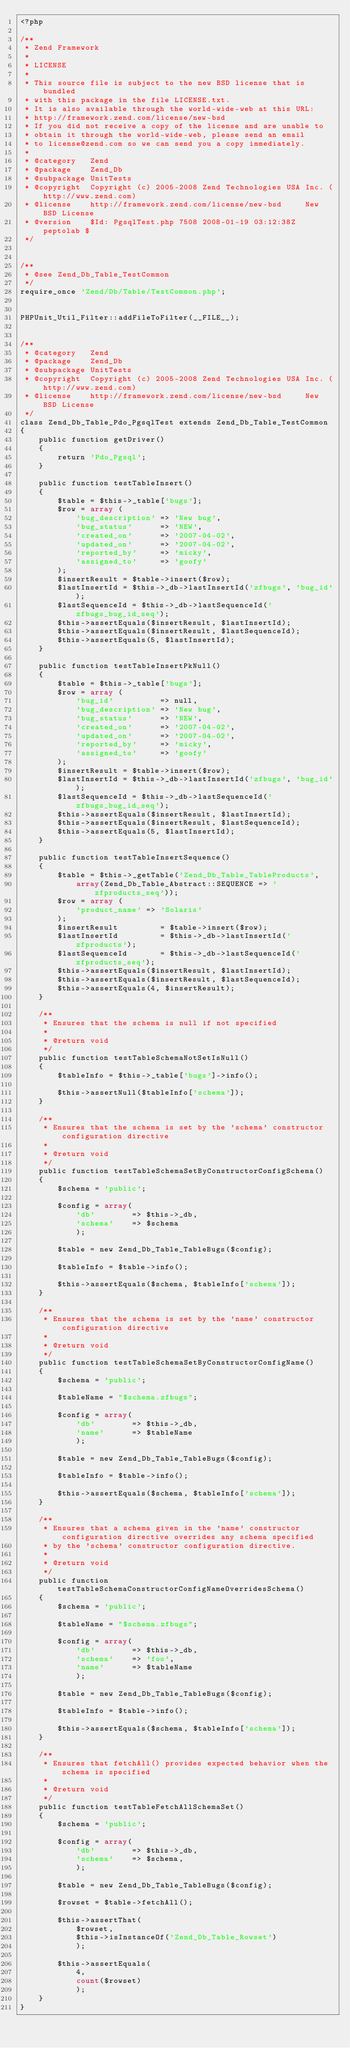<code> <loc_0><loc_0><loc_500><loc_500><_PHP_><?php

/**
 * Zend Framework
 *
 * LICENSE
 *
 * This source file is subject to the new BSD license that is bundled
 * with this package in the file LICENSE.txt.
 * It is also available through the world-wide-web at this URL:
 * http://framework.zend.com/license/new-bsd
 * If you did not receive a copy of the license and are unable to
 * obtain it through the world-wide-web, please send an email
 * to license@zend.com so we can send you a copy immediately.
 *
 * @category   Zend
 * @package    Zend_Db
 * @subpackage UnitTests
 * @copyright  Copyright (c) 2005-2008 Zend Technologies USA Inc. (http://www.zend.com)
 * @license    http://framework.zend.com/license/new-bsd     New BSD License
 * @version    $Id: PgsqlTest.php 7508 2008-01-19 03:12:38Z peptolab $
 */


/**
 * @see Zend_Db_Table_TestCommon
 */
require_once 'Zend/Db/Table/TestCommon.php';


PHPUnit_Util_Filter::addFileToFilter(__FILE__);


/**
 * @category   Zend
 * @package    Zend_Db
 * @subpackage UnitTests
 * @copyright  Copyright (c) 2005-2008 Zend Technologies USA Inc. (http://www.zend.com)
 * @license    http://framework.zend.com/license/new-bsd     New BSD License
 */
class Zend_Db_Table_Pdo_PgsqlTest extends Zend_Db_Table_TestCommon
{
    public function getDriver()
    {
        return 'Pdo_Pgsql';
    }

    public function testTableInsert()
    {
        $table = $this->_table['bugs'];
        $row = array (
            'bug_description' => 'New bug',
            'bug_status'      => 'NEW',
            'created_on'      => '2007-04-02',
            'updated_on'      => '2007-04-02',
            'reported_by'     => 'micky',
            'assigned_to'     => 'goofy'
        );
        $insertResult = $table->insert($row);
        $lastInsertId = $this->_db->lastInsertId('zfbugs', 'bug_id');
        $lastSequenceId = $this->_db->lastSequenceId('zfbugs_bug_id_seq');
        $this->assertEquals($insertResult, $lastInsertId);
        $this->assertEquals($insertResult, $lastSequenceId);
        $this->assertEquals(5, $lastInsertId);
    }

    public function testTableInsertPkNull()
    {
        $table = $this->_table['bugs'];
        $row = array (
            'bug_id'          => null,
            'bug_description' => 'New bug',
            'bug_status'      => 'NEW',
            'created_on'      => '2007-04-02',
            'updated_on'      => '2007-04-02',
            'reported_by'     => 'micky',
            'assigned_to'     => 'goofy'
        );
        $insertResult = $table->insert($row);
        $lastInsertId = $this->_db->lastInsertId('zfbugs', 'bug_id');
        $lastSequenceId = $this->_db->lastSequenceId('zfbugs_bug_id_seq');
        $this->assertEquals($insertResult, $lastInsertId);
        $this->assertEquals($insertResult, $lastSequenceId);
        $this->assertEquals(5, $lastInsertId);
    }

    public function testTableInsertSequence()
    {
        $table = $this->_getTable('Zend_Db_Table_TableProducts',
            array(Zend_Db_Table_Abstract::SEQUENCE => 'zfproducts_seq'));
        $row = array (
            'product_name' => 'Solaris'
        );
        $insertResult         = $table->insert($row);
        $lastInsertId         = $this->_db->lastInsertId('zfproducts');
        $lastSequenceId       = $this->_db->lastSequenceId('zfproducts_seq');
        $this->assertEquals($insertResult, $lastInsertId);
        $this->assertEquals($insertResult, $lastSequenceId);
        $this->assertEquals(4, $insertResult);
    }

    /**
     * Ensures that the schema is null if not specified
     *
     * @return void
     */
    public function testTableSchemaNotSetIsNull()
    {
        $tableInfo = $this->_table['bugs']->info();

        $this->assertNull($tableInfo['schema']);
    }

    /**
     * Ensures that the schema is set by the 'schema' constructor configuration directive
     *
     * @return void
     */
    public function testTableSchemaSetByConstructorConfigSchema()
    {
        $schema = 'public';

        $config = array(
            'db'        => $this->_db,
            'schema'    => $schema
            );

        $table = new Zend_Db_Table_TableBugs($config);

        $tableInfo = $table->info();

        $this->assertEquals($schema, $tableInfo['schema']);
    }

    /**
     * Ensures that the schema is set by the 'name' constructor configuration directive
     *
     * @return void
     */
    public function testTableSchemaSetByConstructorConfigName()
    {
        $schema = 'public';

        $tableName = "$schema.zfbugs";

        $config = array(
            'db'        => $this->_db,
            'name'      => $tableName
            );

        $table = new Zend_Db_Table_TableBugs($config);

        $tableInfo = $table->info();

        $this->assertEquals($schema, $tableInfo['schema']);
    }

    /**
     * Ensures that a schema given in the 'name' constructor configuration directive overrides any schema specified
     * by the 'schema' constructor configuration directive.
     *
     * @return void
     */
    public function testTableSchemaConstructorConfigNameOverridesSchema()
    {
        $schema = 'public';

        $tableName = "$schema.zfbugs";

        $config = array(
            'db'        => $this->_db,
            'schema'    => 'foo',
            'name'      => $tableName
            );

        $table = new Zend_Db_Table_TableBugs($config);

        $tableInfo = $table->info();

        $this->assertEquals($schema, $tableInfo['schema']);
    }

    /**
     * Ensures that fetchAll() provides expected behavior when the schema is specified
     *
     * @return void
     */
    public function testTableFetchAllSchemaSet()
    {
        $schema = 'public';

        $config = array(
            'db'        => $this->_db,
            'schema'    => $schema,
            );

        $table = new Zend_Db_Table_TableBugs($config);

        $rowset = $table->fetchAll();

        $this->assertThat(
            $rowset,
            $this->isInstanceOf('Zend_Db_Table_Rowset')
            );

        $this->assertEquals(
            4,
            count($rowset)
            );
    }
}
</code> 